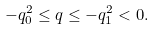Convert formula to latex. <formula><loc_0><loc_0><loc_500><loc_500>- q _ { 0 } ^ { 2 } \leq q \leq - q _ { 1 } ^ { 2 } < 0 .</formula> 